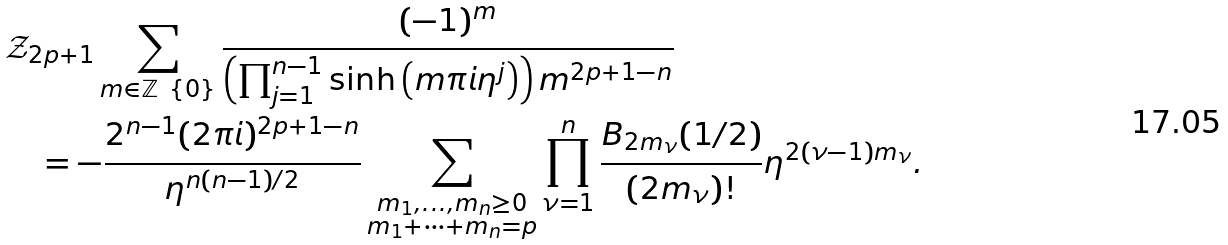<formula> <loc_0><loc_0><loc_500><loc_500>& \mathcal { Z } _ { 2 p + 1 } \sum _ { m \in \mathbb { Z } \ \{ 0 \} } \frac { ( - 1 ) ^ { m } } { \left ( \prod _ { j = 1 } ^ { n - 1 } { \sinh \left ( m \pi i \eta ^ { j } \right ) } \right ) m ^ { 2 p + 1 - n } } \\ & \quad = - \frac { 2 ^ { n - 1 } ( 2 \pi i ) ^ { 2 p + 1 - n } } { \eta ^ { n ( n - 1 ) / 2 } } \sum _ { \substack { m _ { 1 } , \dots , m _ { n } \geq 0 \\ m _ { 1 } + \cdots + m _ { n } = p } } \prod _ { \nu = 1 } ^ { n } \frac { B _ { 2 m _ { \nu } } ( 1 / 2 ) } { ( 2 m _ { \nu } ) ! } \eta ^ { 2 ( \nu - 1 ) m _ { \nu } } .</formula> 